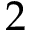Convert formula to latex. <formula><loc_0><loc_0><loc_500><loc_500>2</formula> 